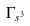<formula> <loc_0><loc_0><loc_500><loc_500>\Gamma _ { s ^ { 3 } }</formula> 